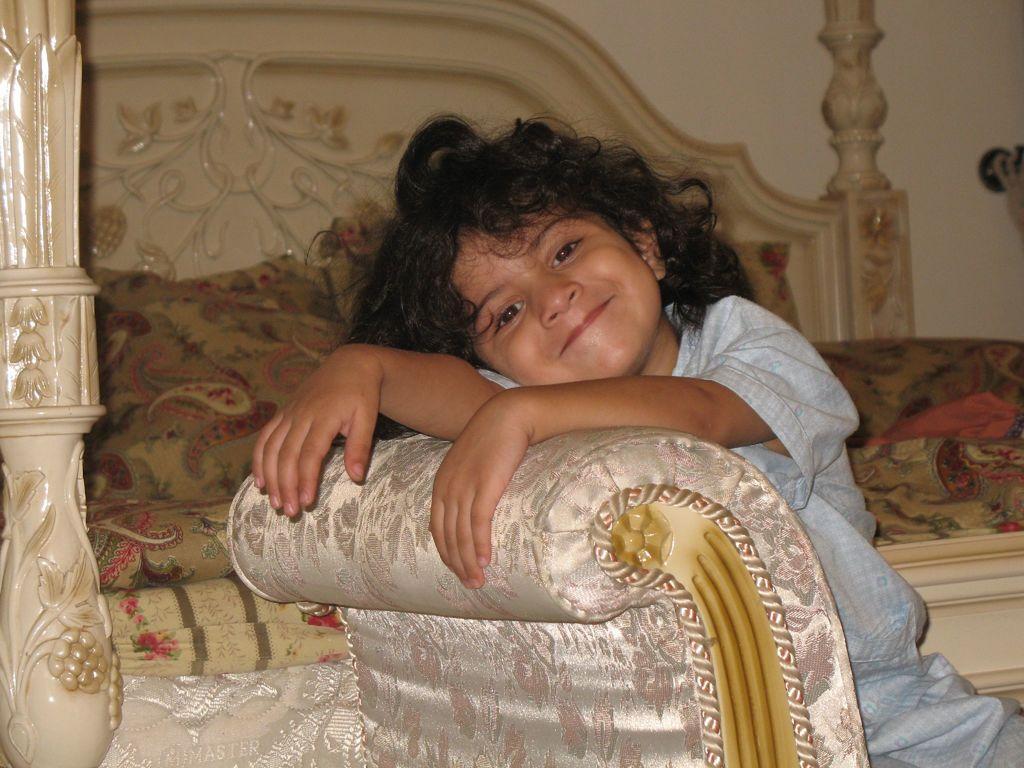How would you summarize this image in a sentence or two? In this picture we can see a bed on which there is a blanket and a pillow. Here in front of the picture we can see a kid sitting and laying hands on the sofa and giving a smile to the camera. 